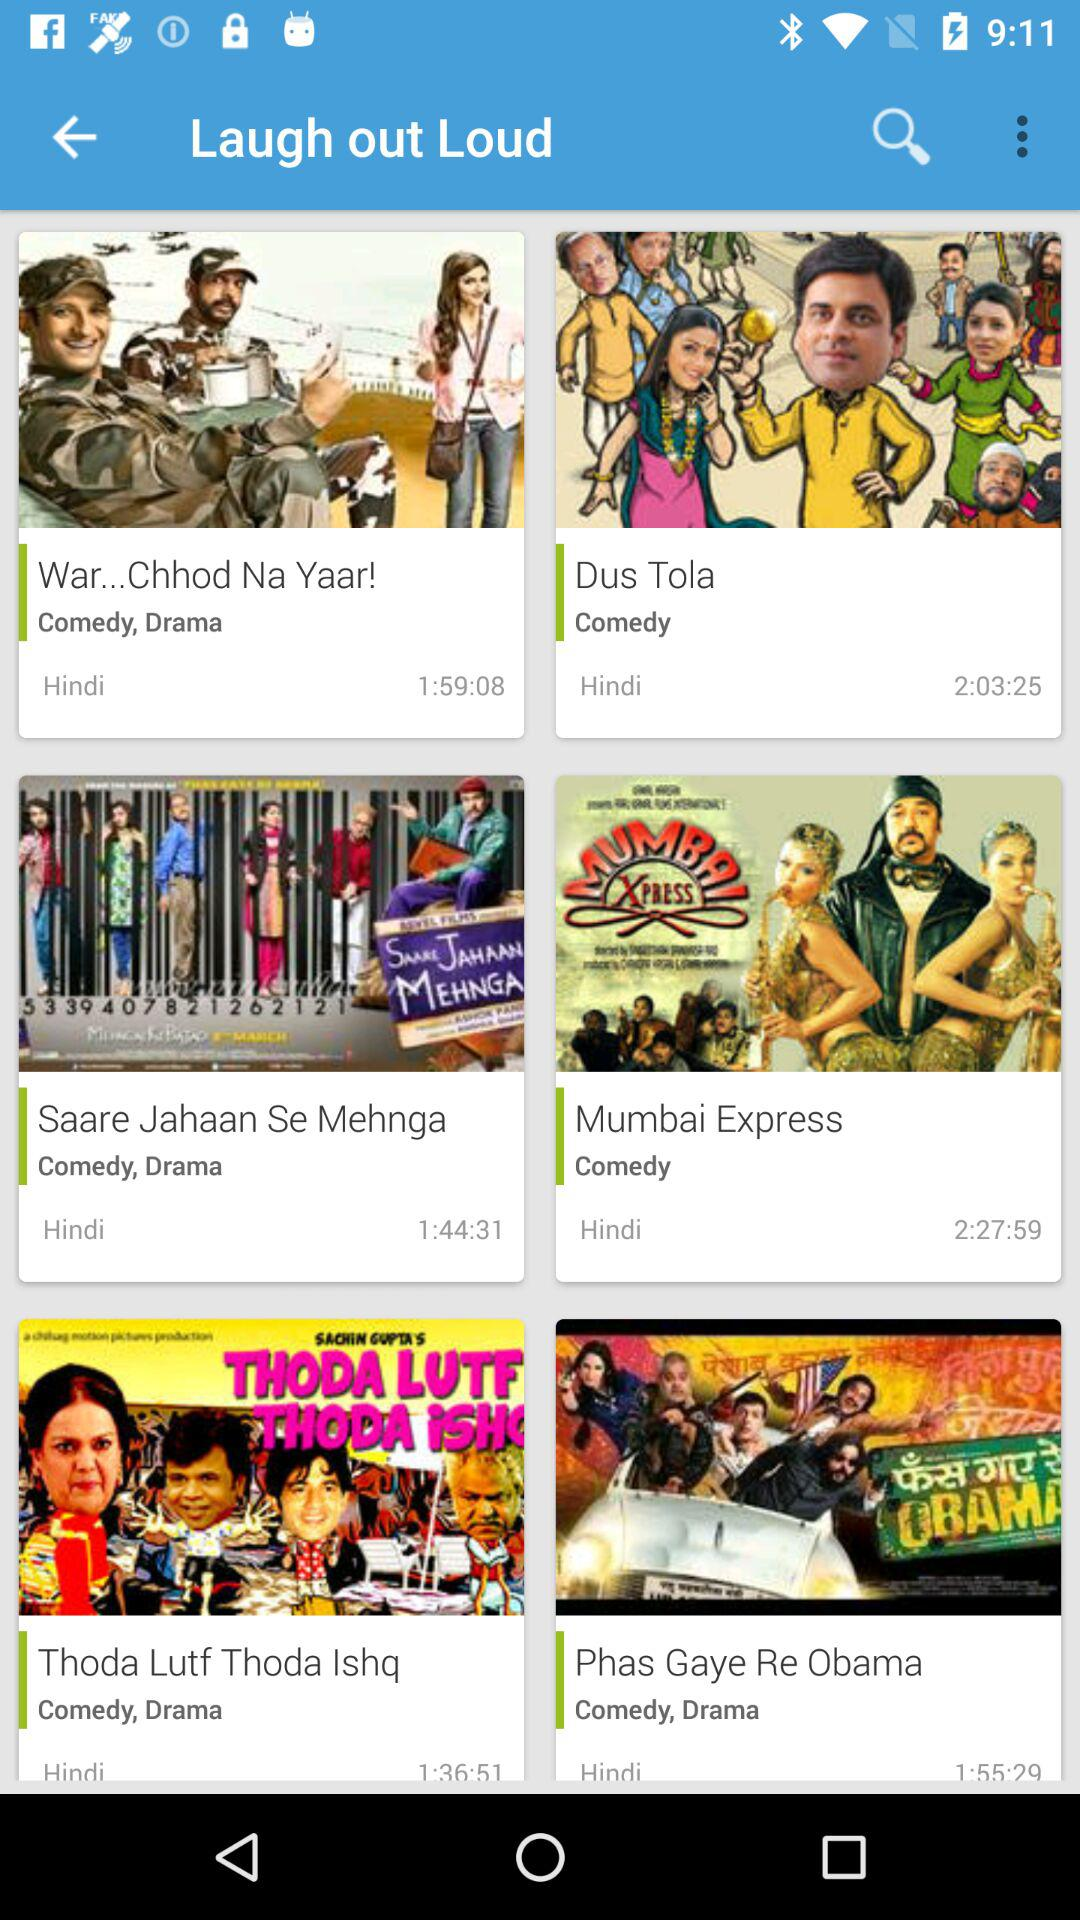What is the duration of "Dus Tola"? The duration is 2 hours 3 minutes 25 seconds. 